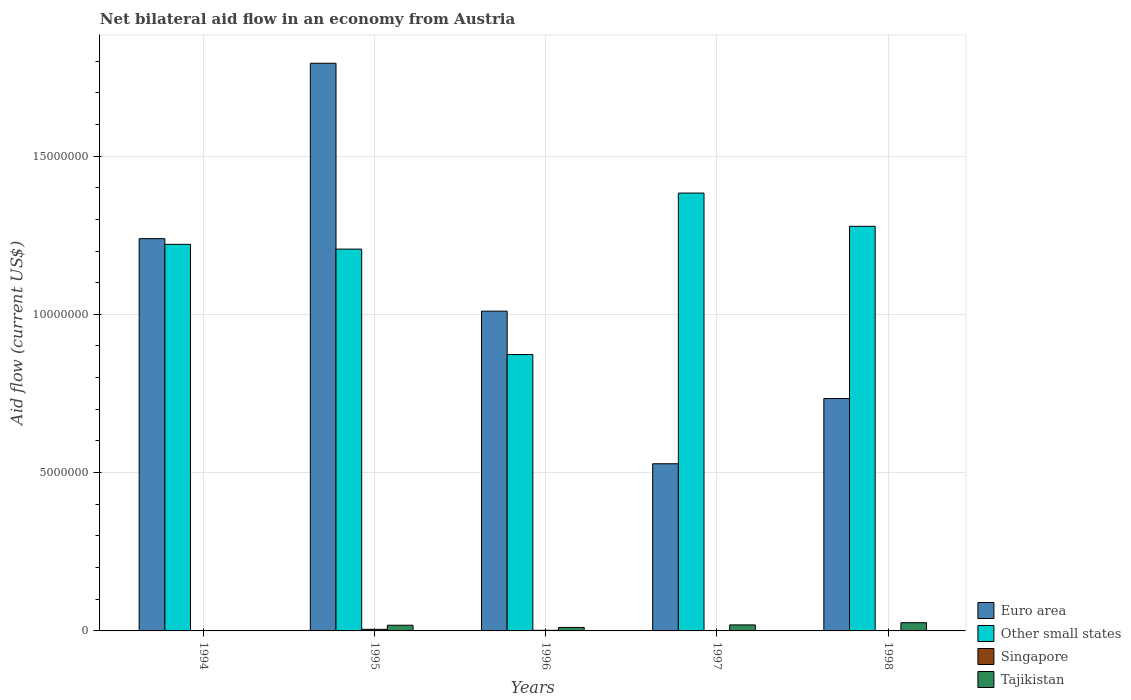How many different coloured bars are there?
Offer a terse response. 4. Are the number of bars per tick equal to the number of legend labels?
Provide a succinct answer. No. Are the number of bars on each tick of the X-axis equal?
Make the answer very short. No. How many bars are there on the 2nd tick from the right?
Give a very brief answer. 3. Across all years, what is the maximum net bilateral aid flow in Euro area?
Provide a short and direct response. 1.79e+07. Across all years, what is the minimum net bilateral aid flow in Euro area?
Ensure brevity in your answer.  5.28e+06. In which year was the net bilateral aid flow in Other small states maximum?
Your response must be concise. 1997. What is the total net bilateral aid flow in Tajikistan in the graph?
Provide a short and direct response. 7.50e+05. What is the difference between the net bilateral aid flow in Euro area in 1995 and that in 1996?
Your answer should be very brief. 7.83e+06. What is the difference between the net bilateral aid flow in Singapore in 1997 and the net bilateral aid flow in Other small states in 1996?
Make the answer very short. -8.73e+06. What is the average net bilateral aid flow in Euro area per year?
Keep it short and to the point. 1.06e+07. In the year 1995, what is the difference between the net bilateral aid flow in Other small states and net bilateral aid flow in Singapore?
Your response must be concise. 1.20e+07. In how many years, is the net bilateral aid flow in Singapore greater than 10000000 US$?
Provide a short and direct response. 0. What is the ratio of the net bilateral aid flow in Other small states in 1995 to that in 1997?
Your answer should be compact. 0.87. What is the difference between the highest and the lowest net bilateral aid flow in Other small states?
Ensure brevity in your answer.  5.10e+06. Is the sum of the net bilateral aid flow in Tajikistan in 1996 and 1997 greater than the maximum net bilateral aid flow in Euro area across all years?
Your answer should be compact. No. Is it the case that in every year, the sum of the net bilateral aid flow in Singapore and net bilateral aid flow in Other small states is greater than the net bilateral aid flow in Tajikistan?
Your answer should be compact. Yes. How many bars are there?
Give a very brief answer. 18. What is the difference between two consecutive major ticks on the Y-axis?
Provide a short and direct response. 5.00e+06. Are the values on the major ticks of Y-axis written in scientific E-notation?
Keep it short and to the point. No. Does the graph contain any zero values?
Make the answer very short. Yes. Does the graph contain grids?
Offer a terse response. Yes. How many legend labels are there?
Give a very brief answer. 4. What is the title of the graph?
Your answer should be compact. Net bilateral aid flow in an economy from Austria. What is the label or title of the X-axis?
Offer a very short reply. Years. What is the label or title of the Y-axis?
Offer a very short reply. Aid flow (current US$). What is the Aid flow (current US$) of Euro area in 1994?
Provide a short and direct response. 1.24e+07. What is the Aid flow (current US$) in Other small states in 1994?
Provide a short and direct response. 1.22e+07. What is the Aid flow (current US$) of Tajikistan in 1994?
Offer a very short reply. 10000. What is the Aid flow (current US$) in Euro area in 1995?
Your response must be concise. 1.79e+07. What is the Aid flow (current US$) of Other small states in 1995?
Make the answer very short. 1.21e+07. What is the Aid flow (current US$) in Singapore in 1995?
Keep it short and to the point. 5.00e+04. What is the Aid flow (current US$) in Tajikistan in 1995?
Your response must be concise. 1.80e+05. What is the Aid flow (current US$) of Euro area in 1996?
Give a very brief answer. 1.01e+07. What is the Aid flow (current US$) in Other small states in 1996?
Offer a very short reply. 8.73e+06. What is the Aid flow (current US$) of Singapore in 1996?
Your answer should be compact. 2.00e+04. What is the Aid flow (current US$) in Euro area in 1997?
Ensure brevity in your answer.  5.28e+06. What is the Aid flow (current US$) in Other small states in 1997?
Your answer should be compact. 1.38e+07. What is the Aid flow (current US$) in Tajikistan in 1997?
Your answer should be compact. 1.90e+05. What is the Aid flow (current US$) of Euro area in 1998?
Keep it short and to the point. 7.34e+06. What is the Aid flow (current US$) in Other small states in 1998?
Provide a succinct answer. 1.28e+07. What is the Aid flow (current US$) in Tajikistan in 1998?
Ensure brevity in your answer.  2.60e+05. Across all years, what is the maximum Aid flow (current US$) in Euro area?
Offer a terse response. 1.79e+07. Across all years, what is the maximum Aid flow (current US$) of Other small states?
Provide a short and direct response. 1.38e+07. Across all years, what is the maximum Aid flow (current US$) in Singapore?
Provide a short and direct response. 5.00e+04. Across all years, what is the minimum Aid flow (current US$) in Euro area?
Make the answer very short. 5.28e+06. Across all years, what is the minimum Aid flow (current US$) of Other small states?
Provide a succinct answer. 8.73e+06. What is the total Aid flow (current US$) in Euro area in the graph?
Offer a very short reply. 5.30e+07. What is the total Aid flow (current US$) in Other small states in the graph?
Provide a succinct answer. 5.96e+07. What is the total Aid flow (current US$) of Tajikistan in the graph?
Give a very brief answer. 7.50e+05. What is the difference between the Aid flow (current US$) in Euro area in 1994 and that in 1995?
Your answer should be very brief. -5.54e+06. What is the difference between the Aid flow (current US$) of Euro area in 1994 and that in 1996?
Your response must be concise. 2.29e+06. What is the difference between the Aid flow (current US$) of Other small states in 1994 and that in 1996?
Ensure brevity in your answer.  3.48e+06. What is the difference between the Aid flow (current US$) in Euro area in 1994 and that in 1997?
Provide a short and direct response. 7.11e+06. What is the difference between the Aid flow (current US$) in Other small states in 1994 and that in 1997?
Your response must be concise. -1.62e+06. What is the difference between the Aid flow (current US$) in Euro area in 1994 and that in 1998?
Provide a succinct answer. 5.05e+06. What is the difference between the Aid flow (current US$) in Other small states in 1994 and that in 1998?
Give a very brief answer. -5.70e+05. What is the difference between the Aid flow (current US$) in Euro area in 1995 and that in 1996?
Make the answer very short. 7.83e+06. What is the difference between the Aid flow (current US$) in Other small states in 1995 and that in 1996?
Your answer should be compact. 3.33e+06. What is the difference between the Aid flow (current US$) of Euro area in 1995 and that in 1997?
Provide a succinct answer. 1.26e+07. What is the difference between the Aid flow (current US$) in Other small states in 1995 and that in 1997?
Offer a very short reply. -1.77e+06. What is the difference between the Aid flow (current US$) in Tajikistan in 1995 and that in 1997?
Provide a short and direct response. -10000. What is the difference between the Aid flow (current US$) of Euro area in 1995 and that in 1998?
Provide a short and direct response. 1.06e+07. What is the difference between the Aid flow (current US$) of Other small states in 1995 and that in 1998?
Your answer should be compact. -7.20e+05. What is the difference between the Aid flow (current US$) of Euro area in 1996 and that in 1997?
Give a very brief answer. 4.82e+06. What is the difference between the Aid flow (current US$) of Other small states in 1996 and that in 1997?
Provide a succinct answer. -5.10e+06. What is the difference between the Aid flow (current US$) of Tajikistan in 1996 and that in 1997?
Keep it short and to the point. -8.00e+04. What is the difference between the Aid flow (current US$) of Euro area in 1996 and that in 1998?
Your response must be concise. 2.76e+06. What is the difference between the Aid flow (current US$) in Other small states in 1996 and that in 1998?
Make the answer very short. -4.05e+06. What is the difference between the Aid flow (current US$) in Tajikistan in 1996 and that in 1998?
Offer a very short reply. -1.50e+05. What is the difference between the Aid flow (current US$) of Euro area in 1997 and that in 1998?
Your response must be concise. -2.06e+06. What is the difference between the Aid flow (current US$) in Other small states in 1997 and that in 1998?
Offer a terse response. 1.05e+06. What is the difference between the Aid flow (current US$) in Tajikistan in 1997 and that in 1998?
Ensure brevity in your answer.  -7.00e+04. What is the difference between the Aid flow (current US$) in Euro area in 1994 and the Aid flow (current US$) in Other small states in 1995?
Your answer should be compact. 3.30e+05. What is the difference between the Aid flow (current US$) in Euro area in 1994 and the Aid flow (current US$) in Singapore in 1995?
Provide a succinct answer. 1.23e+07. What is the difference between the Aid flow (current US$) in Euro area in 1994 and the Aid flow (current US$) in Tajikistan in 1995?
Keep it short and to the point. 1.22e+07. What is the difference between the Aid flow (current US$) in Other small states in 1994 and the Aid flow (current US$) in Singapore in 1995?
Ensure brevity in your answer.  1.22e+07. What is the difference between the Aid flow (current US$) of Other small states in 1994 and the Aid flow (current US$) of Tajikistan in 1995?
Provide a succinct answer. 1.20e+07. What is the difference between the Aid flow (current US$) of Euro area in 1994 and the Aid flow (current US$) of Other small states in 1996?
Your answer should be very brief. 3.66e+06. What is the difference between the Aid flow (current US$) in Euro area in 1994 and the Aid flow (current US$) in Singapore in 1996?
Make the answer very short. 1.24e+07. What is the difference between the Aid flow (current US$) in Euro area in 1994 and the Aid flow (current US$) in Tajikistan in 1996?
Provide a short and direct response. 1.23e+07. What is the difference between the Aid flow (current US$) in Other small states in 1994 and the Aid flow (current US$) in Singapore in 1996?
Offer a very short reply. 1.22e+07. What is the difference between the Aid flow (current US$) in Other small states in 1994 and the Aid flow (current US$) in Tajikistan in 1996?
Ensure brevity in your answer.  1.21e+07. What is the difference between the Aid flow (current US$) in Euro area in 1994 and the Aid flow (current US$) in Other small states in 1997?
Provide a succinct answer. -1.44e+06. What is the difference between the Aid flow (current US$) in Euro area in 1994 and the Aid flow (current US$) in Tajikistan in 1997?
Your answer should be very brief. 1.22e+07. What is the difference between the Aid flow (current US$) in Other small states in 1994 and the Aid flow (current US$) in Tajikistan in 1997?
Offer a very short reply. 1.20e+07. What is the difference between the Aid flow (current US$) of Singapore in 1994 and the Aid flow (current US$) of Tajikistan in 1997?
Your answer should be very brief. -1.80e+05. What is the difference between the Aid flow (current US$) in Euro area in 1994 and the Aid flow (current US$) in Other small states in 1998?
Ensure brevity in your answer.  -3.90e+05. What is the difference between the Aid flow (current US$) in Euro area in 1994 and the Aid flow (current US$) in Tajikistan in 1998?
Make the answer very short. 1.21e+07. What is the difference between the Aid flow (current US$) in Other small states in 1994 and the Aid flow (current US$) in Tajikistan in 1998?
Keep it short and to the point. 1.20e+07. What is the difference between the Aid flow (current US$) of Euro area in 1995 and the Aid flow (current US$) of Other small states in 1996?
Give a very brief answer. 9.20e+06. What is the difference between the Aid flow (current US$) in Euro area in 1995 and the Aid flow (current US$) in Singapore in 1996?
Ensure brevity in your answer.  1.79e+07. What is the difference between the Aid flow (current US$) of Euro area in 1995 and the Aid flow (current US$) of Tajikistan in 1996?
Your answer should be very brief. 1.78e+07. What is the difference between the Aid flow (current US$) in Other small states in 1995 and the Aid flow (current US$) in Singapore in 1996?
Provide a short and direct response. 1.20e+07. What is the difference between the Aid flow (current US$) of Other small states in 1995 and the Aid flow (current US$) of Tajikistan in 1996?
Keep it short and to the point. 1.20e+07. What is the difference between the Aid flow (current US$) of Singapore in 1995 and the Aid flow (current US$) of Tajikistan in 1996?
Keep it short and to the point. -6.00e+04. What is the difference between the Aid flow (current US$) of Euro area in 1995 and the Aid flow (current US$) of Other small states in 1997?
Your response must be concise. 4.10e+06. What is the difference between the Aid flow (current US$) in Euro area in 1995 and the Aid flow (current US$) in Tajikistan in 1997?
Make the answer very short. 1.77e+07. What is the difference between the Aid flow (current US$) of Other small states in 1995 and the Aid flow (current US$) of Tajikistan in 1997?
Your answer should be compact. 1.19e+07. What is the difference between the Aid flow (current US$) of Euro area in 1995 and the Aid flow (current US$) of Other small states in 1998?
Your answer should be very brief. 5.15e+06. What is the difference between the Aid flow (current US$) of Euro area in 1995 and the Aid flow (current US$) of Tajikistan in 1998?
Keep it short and to the point. 1.77e+07. What is the difference between the Aid flow (current US$) in Other small states in 1995 and the Aid flow (current US$) in Tajikistan in 1998?
Offer a very short reply. 1.18e+07. What is the difference between the Aid flow (current US$) of Euro area in 1996 and the Aid flow (current US$) of Other small states in 1997?
Your answer should be very brief. -3.73e+06. What is the difference between the Aid flow (current US$) in Euro area in 1996 and the Aid flow (current US$) in Tajikistan in 1997?
Your answer should be compact. 9.91e+06. What is the difference between the Aid flow (current US$) of Other small states in 1996 and the Aid flow (current US$) of Tajikistan in 1997?
Keep it short and to the point. 8.54e+06. What is the difference between the Aid flow (current US$) of Euro area in 1996 and the Aid flow (current US$) of Other small states in 1998?
Provide a short and direct response. -2.68e+06. What is the difference between the Aid flow (current US$) in Euro area in 1996 and the Aid flow (current US$) in Tajikistan in 1998?
Give a very brief answer. 9.84e+06. What is the difference between the Aid flow (current US$) in Other small states in 1996 and the Aid flow (current US$) in Tajikistan in 1998?
Keep it short and to the point. 8.47e+06. What is the difference between the Aid flow (current US$) of Euro area in 1997 and the Aid flow (current US$) of Other small states in 1998?
Offer a very short reply. -7.50e+06. What is the difference between the Aid flow (current US$) in Euro area in 1997 and the Aid flow (current US$) in Tajikistan in 1998?
Keep it short and to the point. 5.02e+06. What is the difference between the Aid flow (current US$) of Other small states in 1997 and the Aid flow (current US$) of Tajikistan in 1998?
Offer a very short reply. 1.36e+07. What is the average Aid flow (current US$) of Euro area per year?
Give a very brief answer. 1.06e+07. What is the average Aid flow (current US$) of Other small states per year?
Offer a terse response. 1.19e+07. What is the average Aid flow (current US$) in Singapore per year?
Provide a short and direct response. 1.60e+04. In the year 1994, what is the difference between the Aid flow (current US$) in Euro area and Aid flow (current US$) in Other small states?
Offer a terse response. 1.80e+05. In the year 1994, what is the difference between the Aid flow (current US$) in Euro area and Aid flow (current US$) in Singapore?
Make the answer very short. 1.24e+07. In the year 1994, what is the difference between the Aid flow (current US$) in Euro area and Aid flow (current US$) in Tajikistan?
Your answer should be very brief. 1.24e+07. In the year 1994, what is the difference between the Aid flow (current US$) of Other small states and Aid flow (current US$) of Singapore?
Your answer should be very brief. 1.22e+07. In the year 1994, what is the difference between the Aid flow (current US$) in Other small states and Aid flow (current US$) in Tajikistan?
Your answer should be compact. 1.22e+07. In the year 1994, what is the difference between the Aid flow (current US$) of Singapore and Aid flow (current US$) of Tajikistan?
Your answer should be compact. 0. In the year 1995, what is the difference between the Aid flow (current US$) of Euro area and Aid flow (current US$) of Other small states?
Offer a very short reply. 5.87e+06. In the year 1995, what is the difference between the Aid flow (current US$) of Euro area and Aid flow (current US$) of Singapore?
Give a very brief answer. 1.79e+07. In the year 1995, what is the difference between the Aid flow (current US$) of Euro area and Aid flow (current US$) of Tajikistan?
Provide a succinct answer. 1.78e+07. In the year 1995, what is the difference between the Aid flow (current US$) in Other small states and Aid flow (current US$) in Singapore?
Offer a terse response. 1.20e+07. In the year 1995, what is the difference between the Aid flow (current US$) of Other small states and Aid flow (current US$) of Tajikistan?
Your answer should be very brief. 1.19e+07. In the year 1995, what is the difference between the Aid flow (current US$) in Singapore and Aid flow (current US$) in Tajikistan?
Provide a succinct answer. -1.30e+05. In the year 1996, what is the difference between the Aid flow (current US$) in Euro area and Aid flow (current US$) in Other small states?
Offer a very short reply. 1.37e+06. In the year 1996, what is the difference between the Aid flow (current US$) of Euro area and Aid flow (current US$) of Singapore?
Make the answer very short. 1.01e+07. In the year 1996, what is the difference between the Aid flow (current US$) in Euro area and Aid flow (current US$) in Tajikistan?
Provide a succinct answer. 9.99e+06. In the year 1996, what is the difference between the Aid flow (current US$) in Other small states and Aid flow (current US$) in Singapore?
Your answer should be very brief. 8.71e+06. In the year 1996, what is the difference between the Aid flow (current US$) of Other small states and Aid flow (current US$) of Tajikistan?
Your answer should be very brief. 8.62e+06. In the year 1997, what is the difference between the Aid flow (current US$) in Euro area and Aid flow (current US$) in Other small states?
Ensure brevity in your answer.  -8.55e+06. In the year 1997, what is the difference between the Aid flow (current US$) of Euro area and Aid flow (current US$) of Tajikistan?
Keep it short and to the point. 5.09e+06. In the year 1997, what is the difference between the Aid flow (current US$) of Other small states and Aid flow (current US$) of Tajikistan?
Give a very brief answer. 1.36e+07. In the year 1998, what is the difference between the Aid flow (current US$) of Euro area and Aid flow (current US$) of Other small states?
Keep it short and to the point. -5.44e+06. In the year 1998, what is the difference between the Aid flow (current US$) of Euro area and Aid flow (current US$) of Tajikistan?
Keep it short and to the point. 7.08e+06. In the year 1998, what is the difference between the Aid flow (current US$) of Other small states and Aid flow (current US$) of Tajikistan?
Your answer should be very brief. 1.25e+07. What is the ratio of the Aid flow (current US$) in Euro area in 1994 to that in 1995?
Provide a succinct answer. 0.69. What is the ratio of the Aid flow (current US$) in Other small states in 1994 to that in 1995?
Make the answer very short. 1.01. What is the ratio of the Aid flow (current US$) in Singapore in 1994 to that in 1995?
Your response must be concise. 0.2. What is the ratio of the Aid flow (current US$) in Tajikistan in 1994 to that in 1995?
Offer a very short reply. 0.06. What is the ratio of the Aid flow (current US$) of Euro area in 1994 to that in 1996?
Your answer should be very brief. 1.23. What is the ratio of the Aid flow (current US$) in Other small states in 1994 to that in 1996?
Provide a short and direct response. 1.4. What is the ratio of the Aid flow (current US$) of Tajikistan in 1994 to that in 1996?
Your answer should be compact. 0.09. What is the ratio of the Aid flow (current US$) in Euro area in 1994 to that in 1997?
Ensure brevity in your answer.  2.35. What is the ratio of the Aid flow (current US$) in Other small states in 1994 to that in 1997?
Offer a very short reply. 0.88. What is the ratio of the Aid flow (current US$) of Tajikistan in 1994 to that in 1997?
Your response must be concise. 0.05. What is the ratio of the Aid flow (current US$) of Euro area in 1994 to that in 1998?
Your answer should be compact. 1.69. What is the ratio of the Aid flow (current US$) in Other small states in 1994 to that in 1998?
Provide a succinct answer. 0.96. What is the ratio of the Aid flow (current US$) in Tajikistan in 1994 to that in 1998?
Your response must be concise. 0.04. What is the ratio of the Aid flow (current US$) of Euro area in 1995 to that in 1996?
Ensure brevity in your answer.  1.78. What is the ratio of the Aid flow (current US$) of Other small states in 1995 to that in 1996?
Offer a very short reply. 1.38. What is the ratio of the Aid flow (current US$) in Tajikistan in 1995 to that in 1996?
Give a very brief answer. 1.64. What is the ratio of the Aid flow (current US$) of Euro area in 1995 to that in 1997?
Your response must be concise. 3.4. What is the ratio of the Aid flow (current US$) of Other small states in 1995 to that in 1997?
Keep it short and to the point. 0.87. What is the ratio of the Aid flow (current US$) in Tajikistan in 1995 to that in 1997?
Give a very brief answer. 0.95. What is the ratio of the Aid flow (current US$) in Euro area in 1995 to that in 1998?
Your answer should be very brief. 2.44. What is the ratio of the Aid flow (current US$) in Other small states in 1995 to that in 1998?
Your answer should be very brief. 0.94. What is the ratio of the Aid flow (current US$) in Tajikistan in 1995 to that in 1998?
Make the answer very short. 0.69. What is the ratio of the Aid flow (current US$) in Euro area in 1996 to that in 1997?
Keep it short and to the point. 1.91. What is the ratio of the Aid flow (current US$) of Other small states in 1996 to that in 1997?
Your answer should be very brief. 0.63. What is the ratio of the Aid flow (current US$) of Tajikistan in 1996 to that in 1997?
Give a very brief answer. 0.58. What is the ratio of the Aid flow (current US$) of Euro area in 1996 to that in 1998?
Your answer should be compact. 1.38. What is the ratio of the Aid flow (current US$) in Other small states in 1996 to that in 1998?
Make the answer very short. 0.68. What is the ratio of the Aid flow (current US$) in Tajikistan in 1996 to that in 1998?
Your answer should be compact. 0.42. What is the ratio of the Aid flow (current US$) of Euro area in 1997 to that in 1998?
Your response must be concise. 0.72. What is the ratio of the Aid flow (current US$) in Other small states in 1997 to that in 1998?
Give a very brief answer. 1.08. What is the ratio of the Aid flow (current US$) in Tajikistan in 1997 to that in 1998?
Provide a succinct answer. 0.73. What is the difference between the highest and the second highest Aid flow (current US$) of Euro area?
Offer a terse response. 5.54e+06. What is the difference between the highest and the second highest Aid flow (current US$) in Other small states?
Your response must be concise. 1.05e+06. What is the difference between the highest and the second highest Aid flow (current US$) in Singapore?
Provide a succinct answer. 3.00e+04. What is the difference between the highest and the lowest Aid flow (current US$) in Euro area?
Make the answer very short. 1.26e+07. What is the difference between the highest and the lowest Aid flow (current US$) of Other small states?
Offer a terse response. 5.10e+06. What is the difference between the highest and the lowest Aid flow (current US$) in Singapore?
Keep it short and to the point. 5.00e+04. 